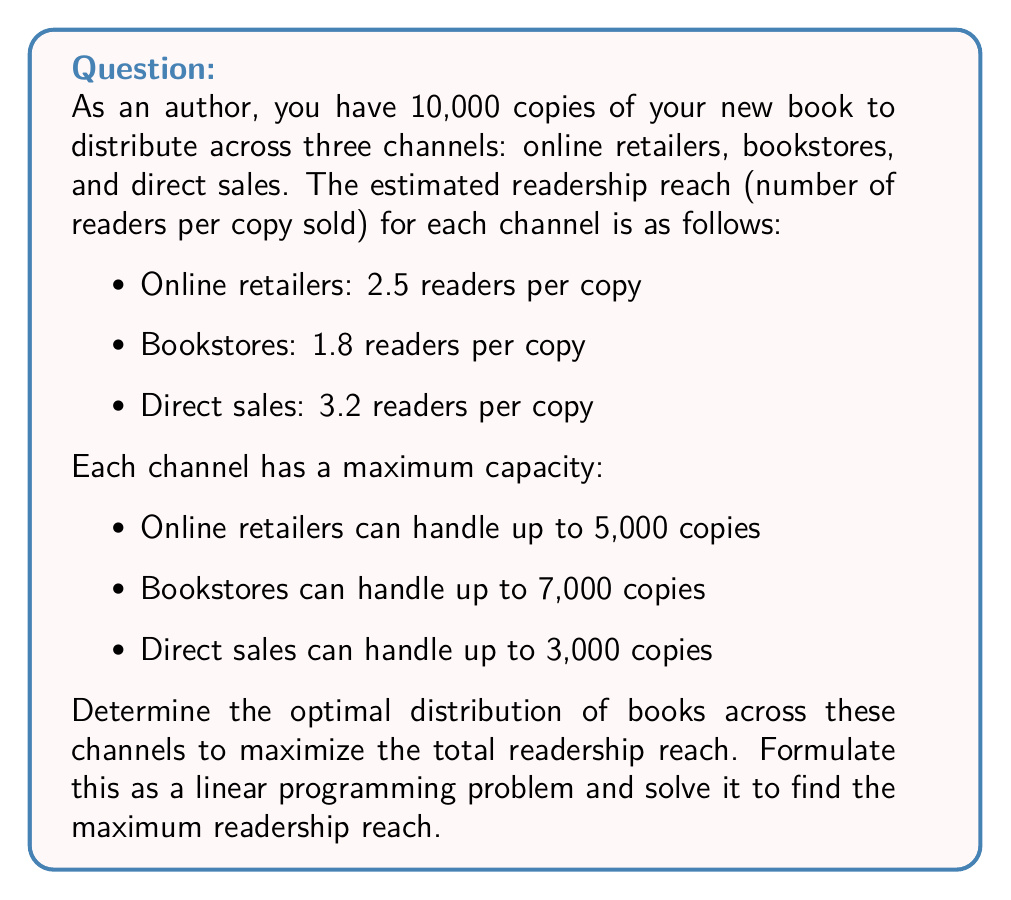What is the answer to this math problem? To solve this optimization problem, we'll follow these steps:

1. Define variables:
Let $x_1$, $x_2$, and $x_3$ represent the number of books distributed through online retailers, bookstores, and direct sales, respectively.

2. Formulate the objective function:
Maximize $Z = 2.5x_1 + 1.8x_2 + 3.2x_3$

3. Define constraints:
a) Total books constraint: $x_1 + x_2 + x_3 = 10000$
b) Channel capacity constraints:
   $x_1 \leq 5000$
   $x_2 \leq 7000$
   $x_3 \leq 3000$
c) Non-negativity constraints: $x_1, x_2, x_3 \geq 0$

4. Solve the linear programming problem:
We can solve this using the simplex method or a graphical approach. In this case, we'll use logical reasoning:

- Direct sales have the highest readership reach (3.2), so we should maximize this channel first. Allocate 3,000 books to direct sales.
- Online retailers have the second-highest reach (2.5), so we should maximize this channel next. Allocate 5,000 books to online retailers.
- The remaining 2,000 books should go to bookstores.

5. Calculate the maximum readership reach:
$Z = 2.5(5000) + 1.8(2000) + 3.2(3000)$
$Z = 12500 + 3600 + 9600$
$Z = 25700$

Therefore, the optimal distribution is:
- Online retailers: 5,000 copies
- Bookstores: 2,000 copies
- Direct sales: 3,000 copies

This distribution maximizes the total readership reach to 25,700 readers.
Answer: The maximum readership reach is 25,700 readers, achieved by distributing 5,000 copies to online retailers, 2,000 copies to bookstores, and 3,000 copies through direct sales. 